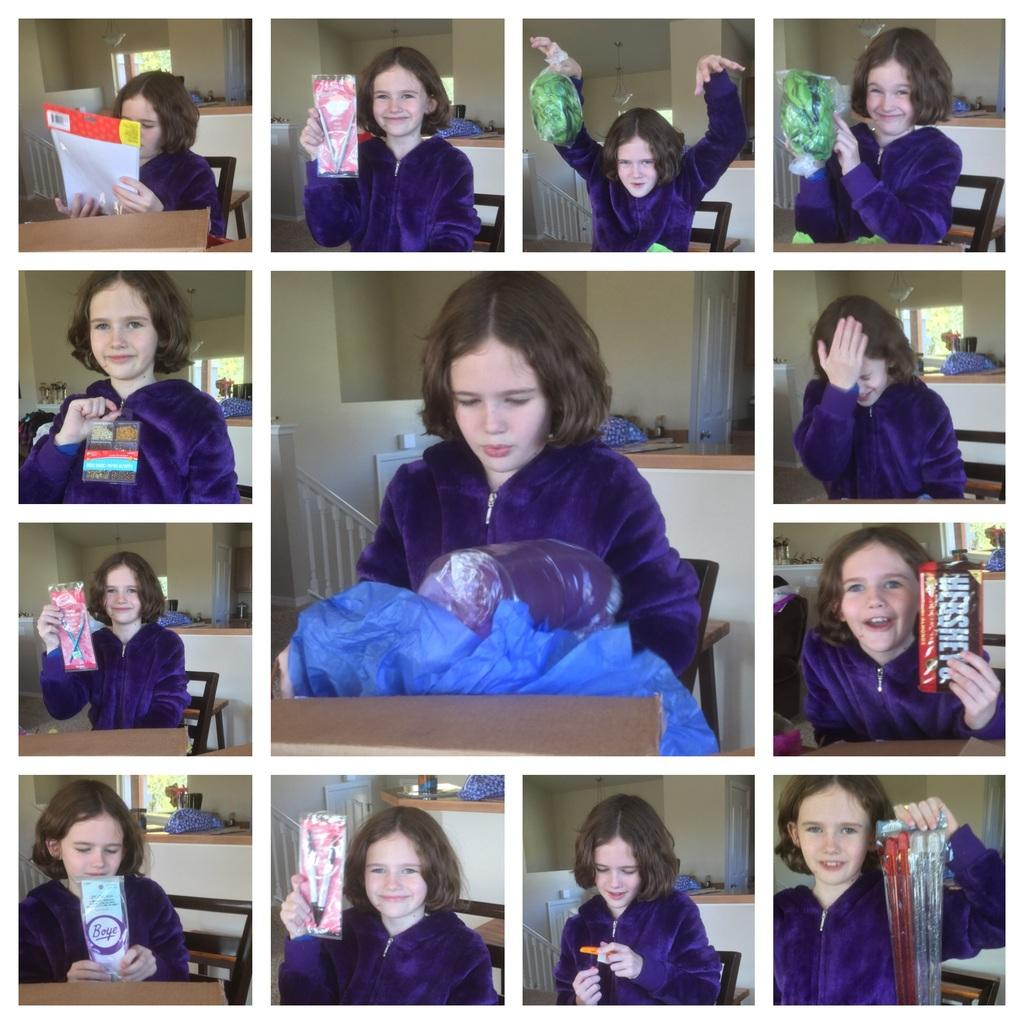What type of image is being described? The image is a collage of pictures. Who is present in each picture? The same girl is present in each picture. What is the girl doing in each picture? The girl is performing different actions in each picture. What is the girl holding in each picture? The girl is holding different objects in each picture. What can be seen in the background of the pictures? There is a wall, a window, and other objects visible in the background of the pictures. What type of coach can be seen in the image? There is no coach present in the image. 